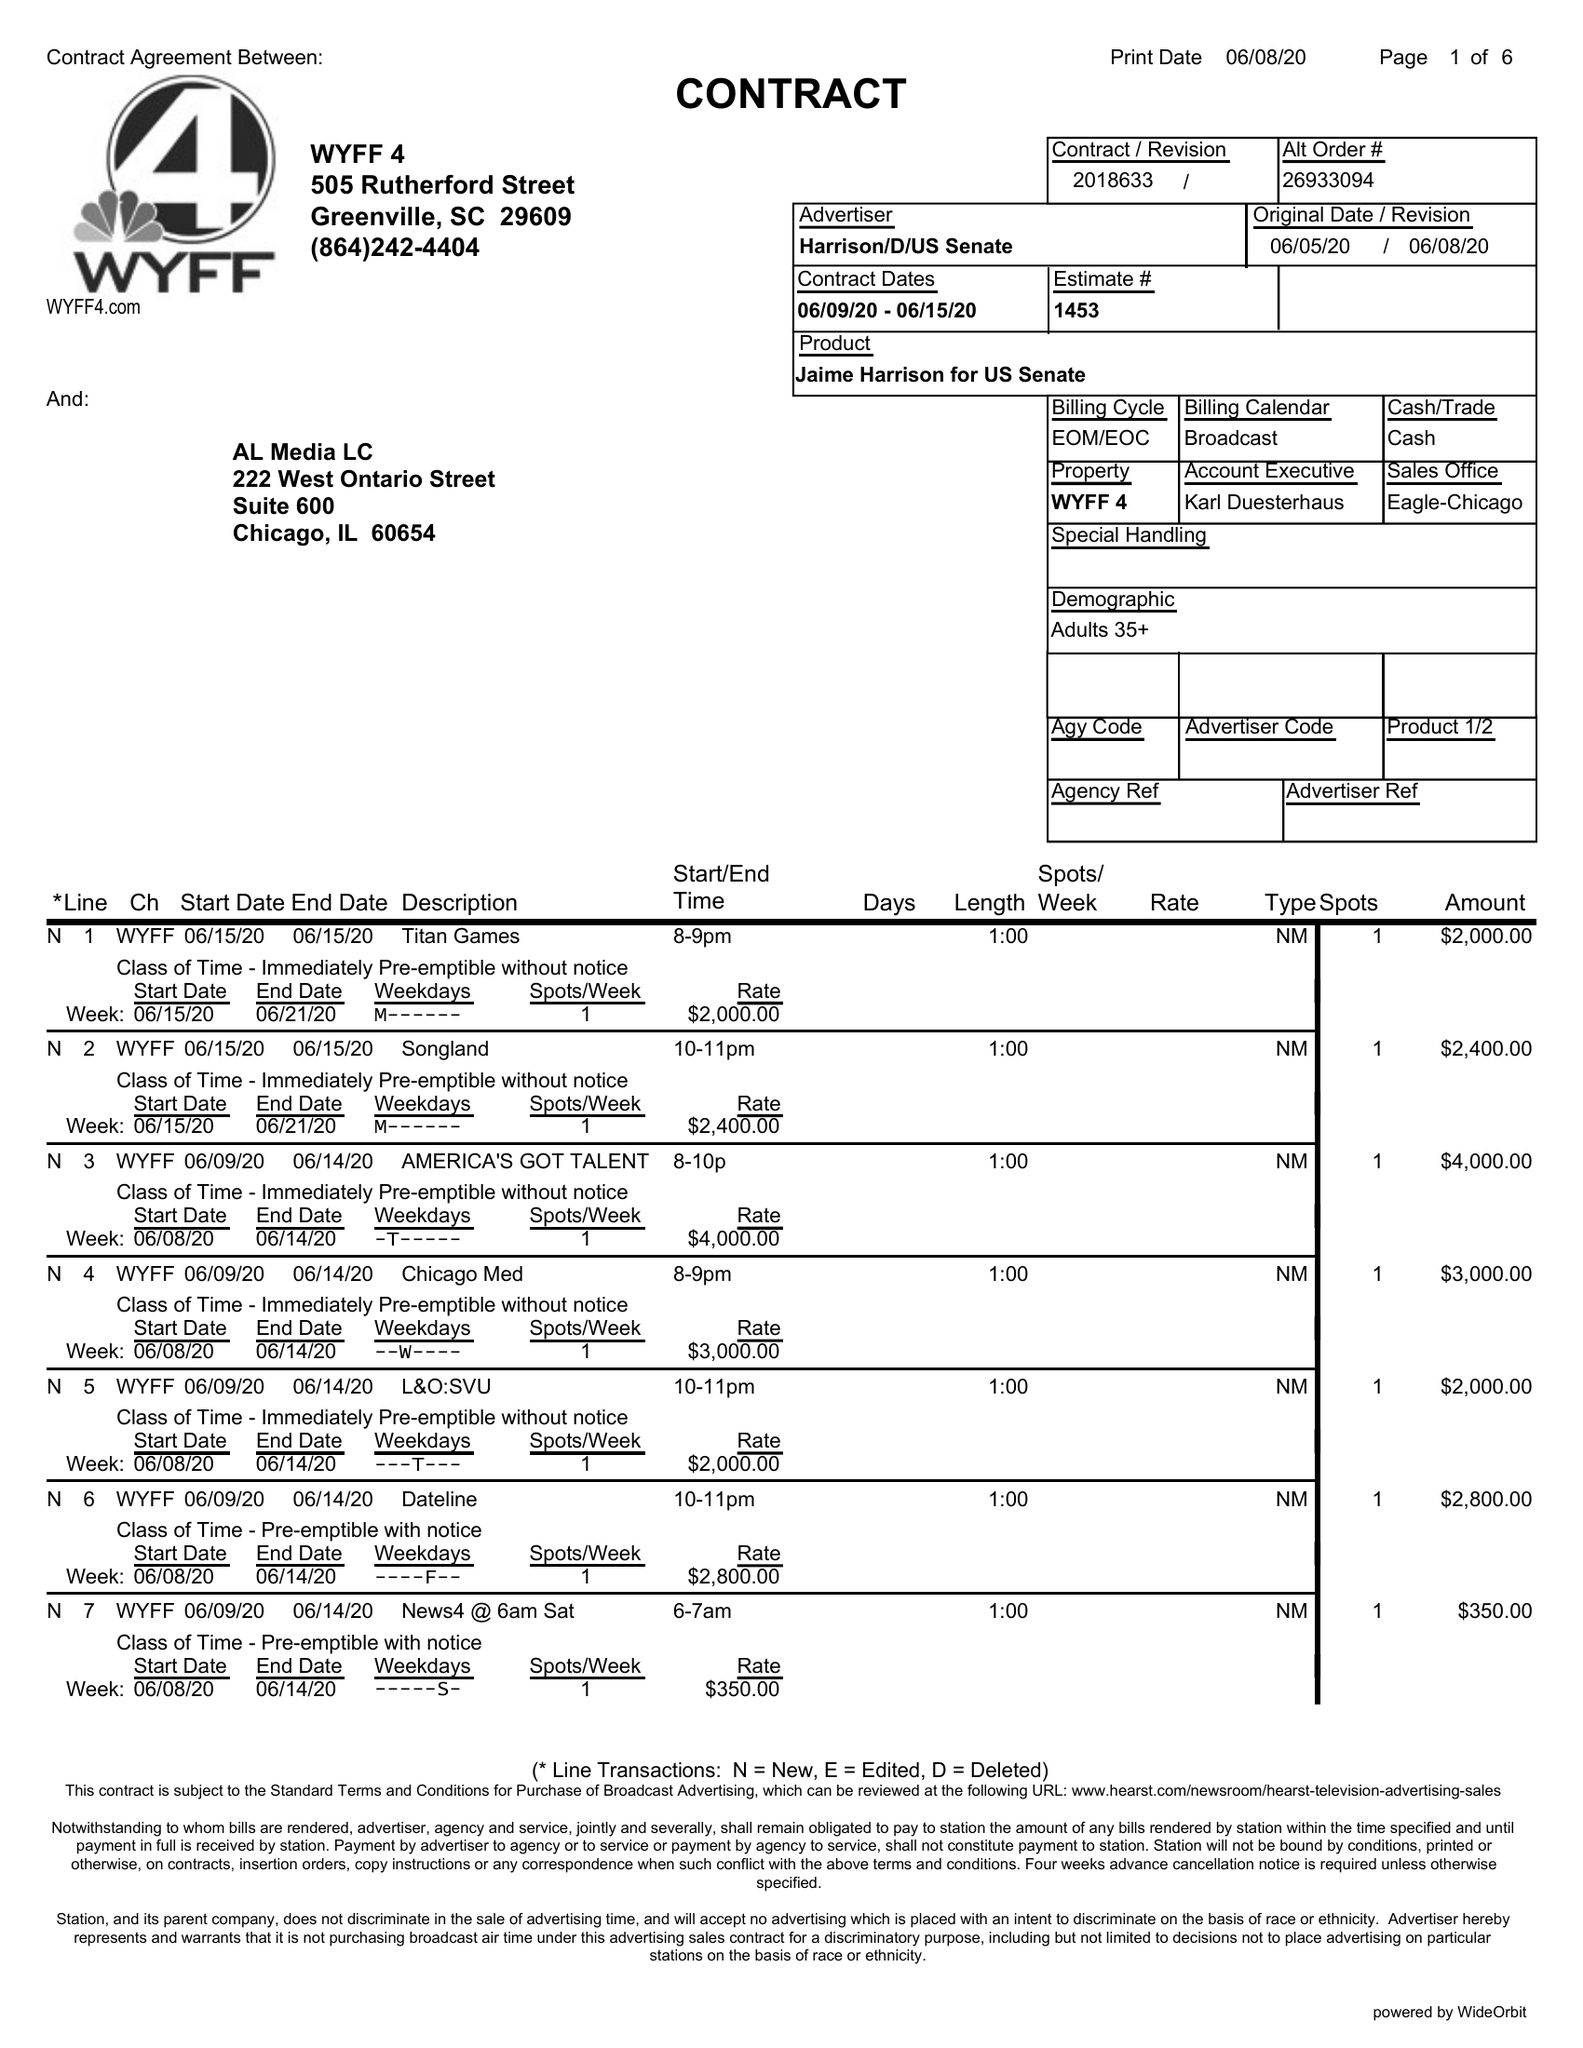What is the value for the flight_to?
Answer the question using a single word or phrase. 06/21/20 